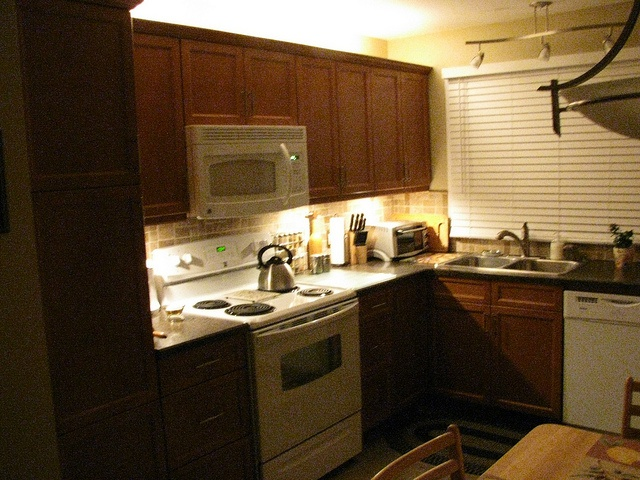Describe the objects in this image and their specific colors. I can see oven in black, ivory, and olive tones, microwave in black, olive, and maroon tones, dining table in black, olive, and maroon tones, chair in black, maroon, and olive tones, and oven in black, tan, maroon, and ivory tones in this image. 